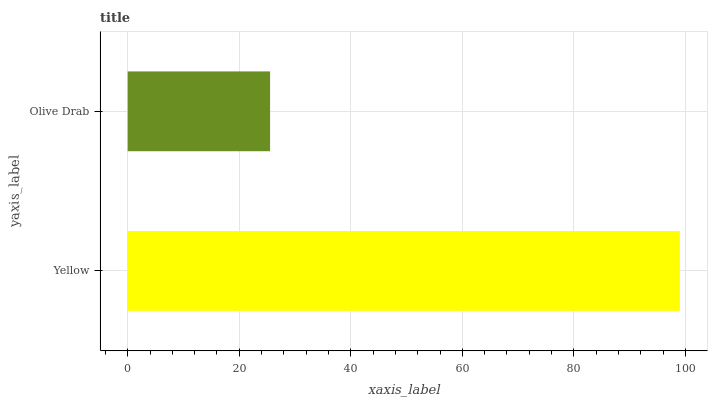Is Olive Drab the minimum?
Answer yes or no. Yes. Is Yellow the maximum?
Answer yes or no. Yes. Is Olive Drab the maximum?
Answer yes or no. No. Is Yellow greater than Olive Drab?
Answer yes or no. Yes. Is Olive Drab less than Yellow?
Answer yes or no. Yes. Is Olive Drab greater than Yellow?
Answer yes or no. No. Is Yellow less than Olive Drab?
Answer yes or no. No. Is Yellow the high median?
Answer yes or no. Yes. Is Olive Drab the low median?
Answer yes or no. Yes. Is Olive Drab the high median?
Answer yes or no. No. Is Yellow the low median?
Answer yes or no. No. 